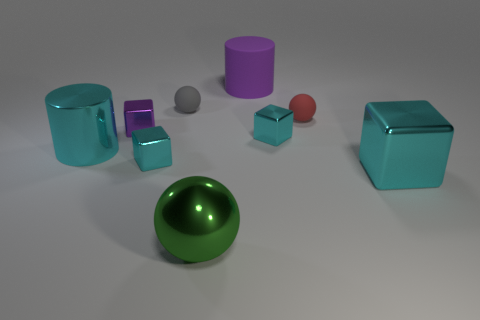What number of objects are either tiny blue metal blocks or cyan shiny objects? In the image, there are a total of 9 objects present. Among these, we can see 3 tiny blue metal blocks and 1 large cyan shiny sphere, making the total number of objects that are either tiny blue metal blocks or cyan shiny objects to be 4. 